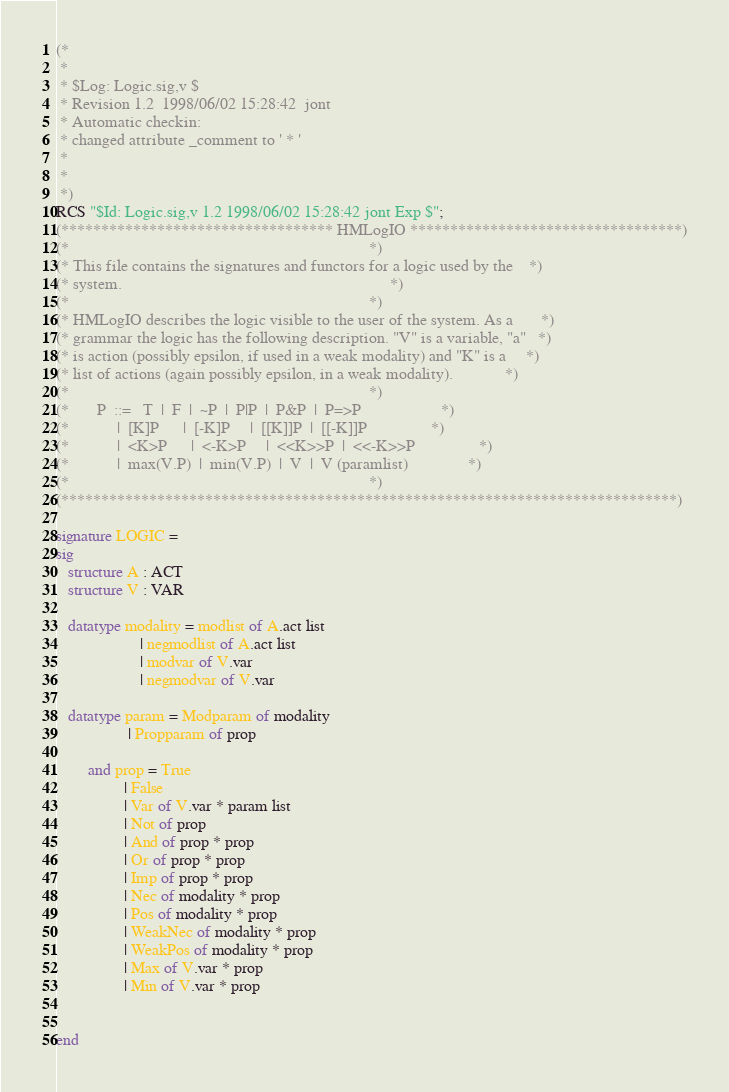<code> <loc_0><loc_0><loc_500><loc_500><_SML_>(*
 *
 * $Log: Logic.sig,v $
 * Revision 1.2  1998/06/02 15:28:42  jont
 * Automatic checkin:
 * changed attribute _comment to ' * '
 *
 *
 *)
RCS "$Id: Logic.sig,v 1.2 1998/06/02 15:28:42 jont Exp $";
(********************************** HMLogIO **********************************)
(*                                                                           *)
(* This file contains the signatures and functors for a logic used by the    *)
(* system.                                                                   *)
(*                                                                           *)
(* HMLogIO describes the logic visible to the user of the system. As a       *)
(* grammar the logic has the following description. "V" is a variable, "a"   *)
(* is action (possibly epsilon, if used in a weak modality) and "K" is a     *)
(* list of actions (again possibly epsilon, in a weak modality).             *)
(*                                                                           *)
(*       P  ::=   T  |  F  |  ~P  |  P|P  |  P&P  |  P=>P                    *)
(*            |  [K]P      |  [-K]P     |  [[K]]P  |  [[-K]]P                *)
(*            |  <K>P      |  <-K>P     |  <<K>>P  |  <<-K>>P                *)
(*            |  max(V.P)  |  min(V.P)  |  V  |  V (paramlist)               *)
(*                                                                           *)
(*****************************************************************************)

signature LOGIC =
sig
   structure A : ACT
   structure V : VAR

   datatype modality = modlist of A.act list
                     | negmodlist of A.act list
                     | modvar of V.var
                     | negmodvar of V.var

   datatype param = Modparam of modality
                  | Propparam of prop

        and prop = True
                 | False
                 | Var of V.var * param list
                 | Not of prop
                 | And of prop * prop
                 | Or of prop * prop
                 | Imp of prop * prop
                 | Nec of modality * prop
                 | Pos of modality * prop
                 | WeakNec of modality * prop
                 | WeakPos of modality * prop
                 | Max of V.var * prop
                 | Min of V.var * prop


end

</code> 